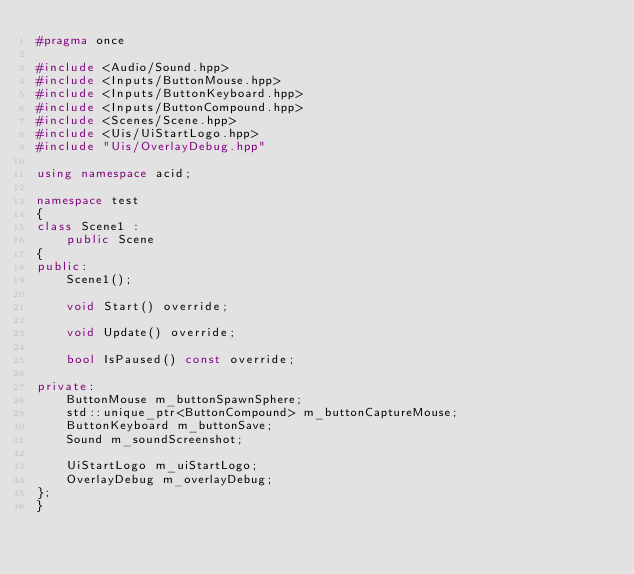<code> <loc_0><loc_0><loc_500><loc_500><_C++_>#pragma once

#include <Audio/Sound.hpp>
#include <Inputs/ButtonMouse.hpp>
#include <Inputs/ButtonKeyboard.hpp>
#include <Inputs/ButtonCompound.hpp>
#include <Scenes/Scene.hpp>
#include <Uis/UiStartLogo.hpp>
#include "Uis/OverlayDebug.hpp"

using namespace acid;

namespace test
{
class Scene1 :
	public Scene
{
public:
	Scene1();

	void Start() override;

	void Update() override;

	bool IsPaused() const override;

private:
	ButtonMouse m_buttonSpawnSphere;
	std::unique_ptr<ButtonCompound> m_buttonCaptureMouse;
	ButtonKeyboard m_buttonSave;
	Sound m_soundScreenshot;

	UiStartLogo m_uiStartLogo;
	OverlayDebug m_overlayDebug;
};
}
</code> 